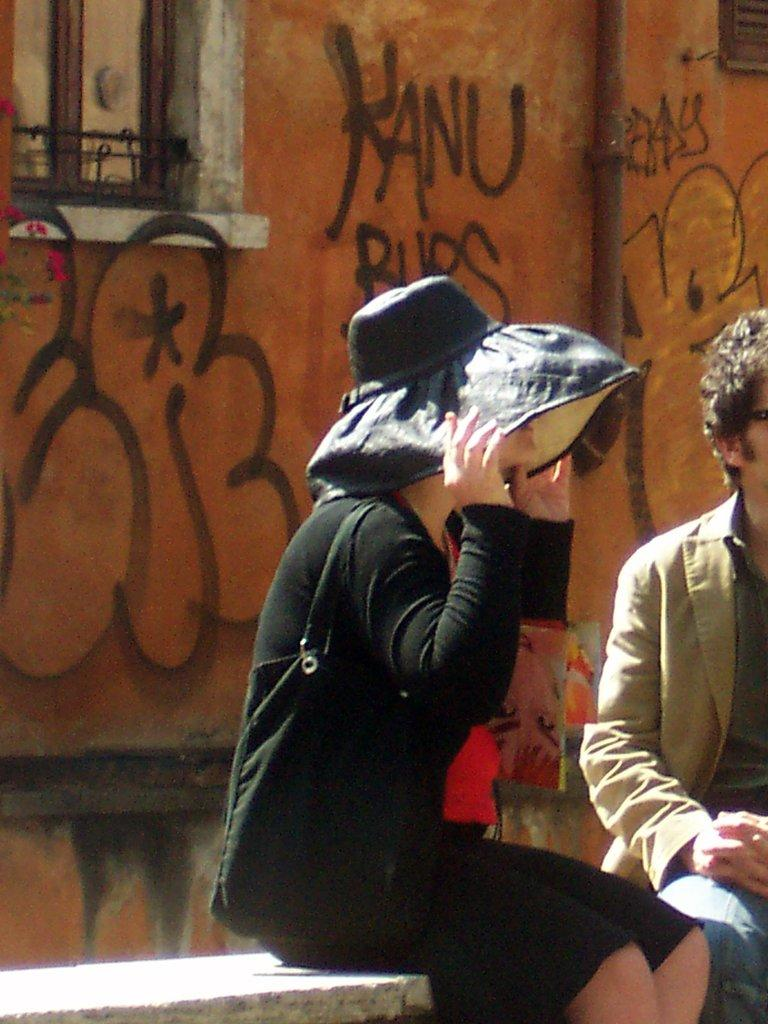<image>
Describe the image concisely. Woman wearing a giant hat in front of a wall which says "Kanu". 